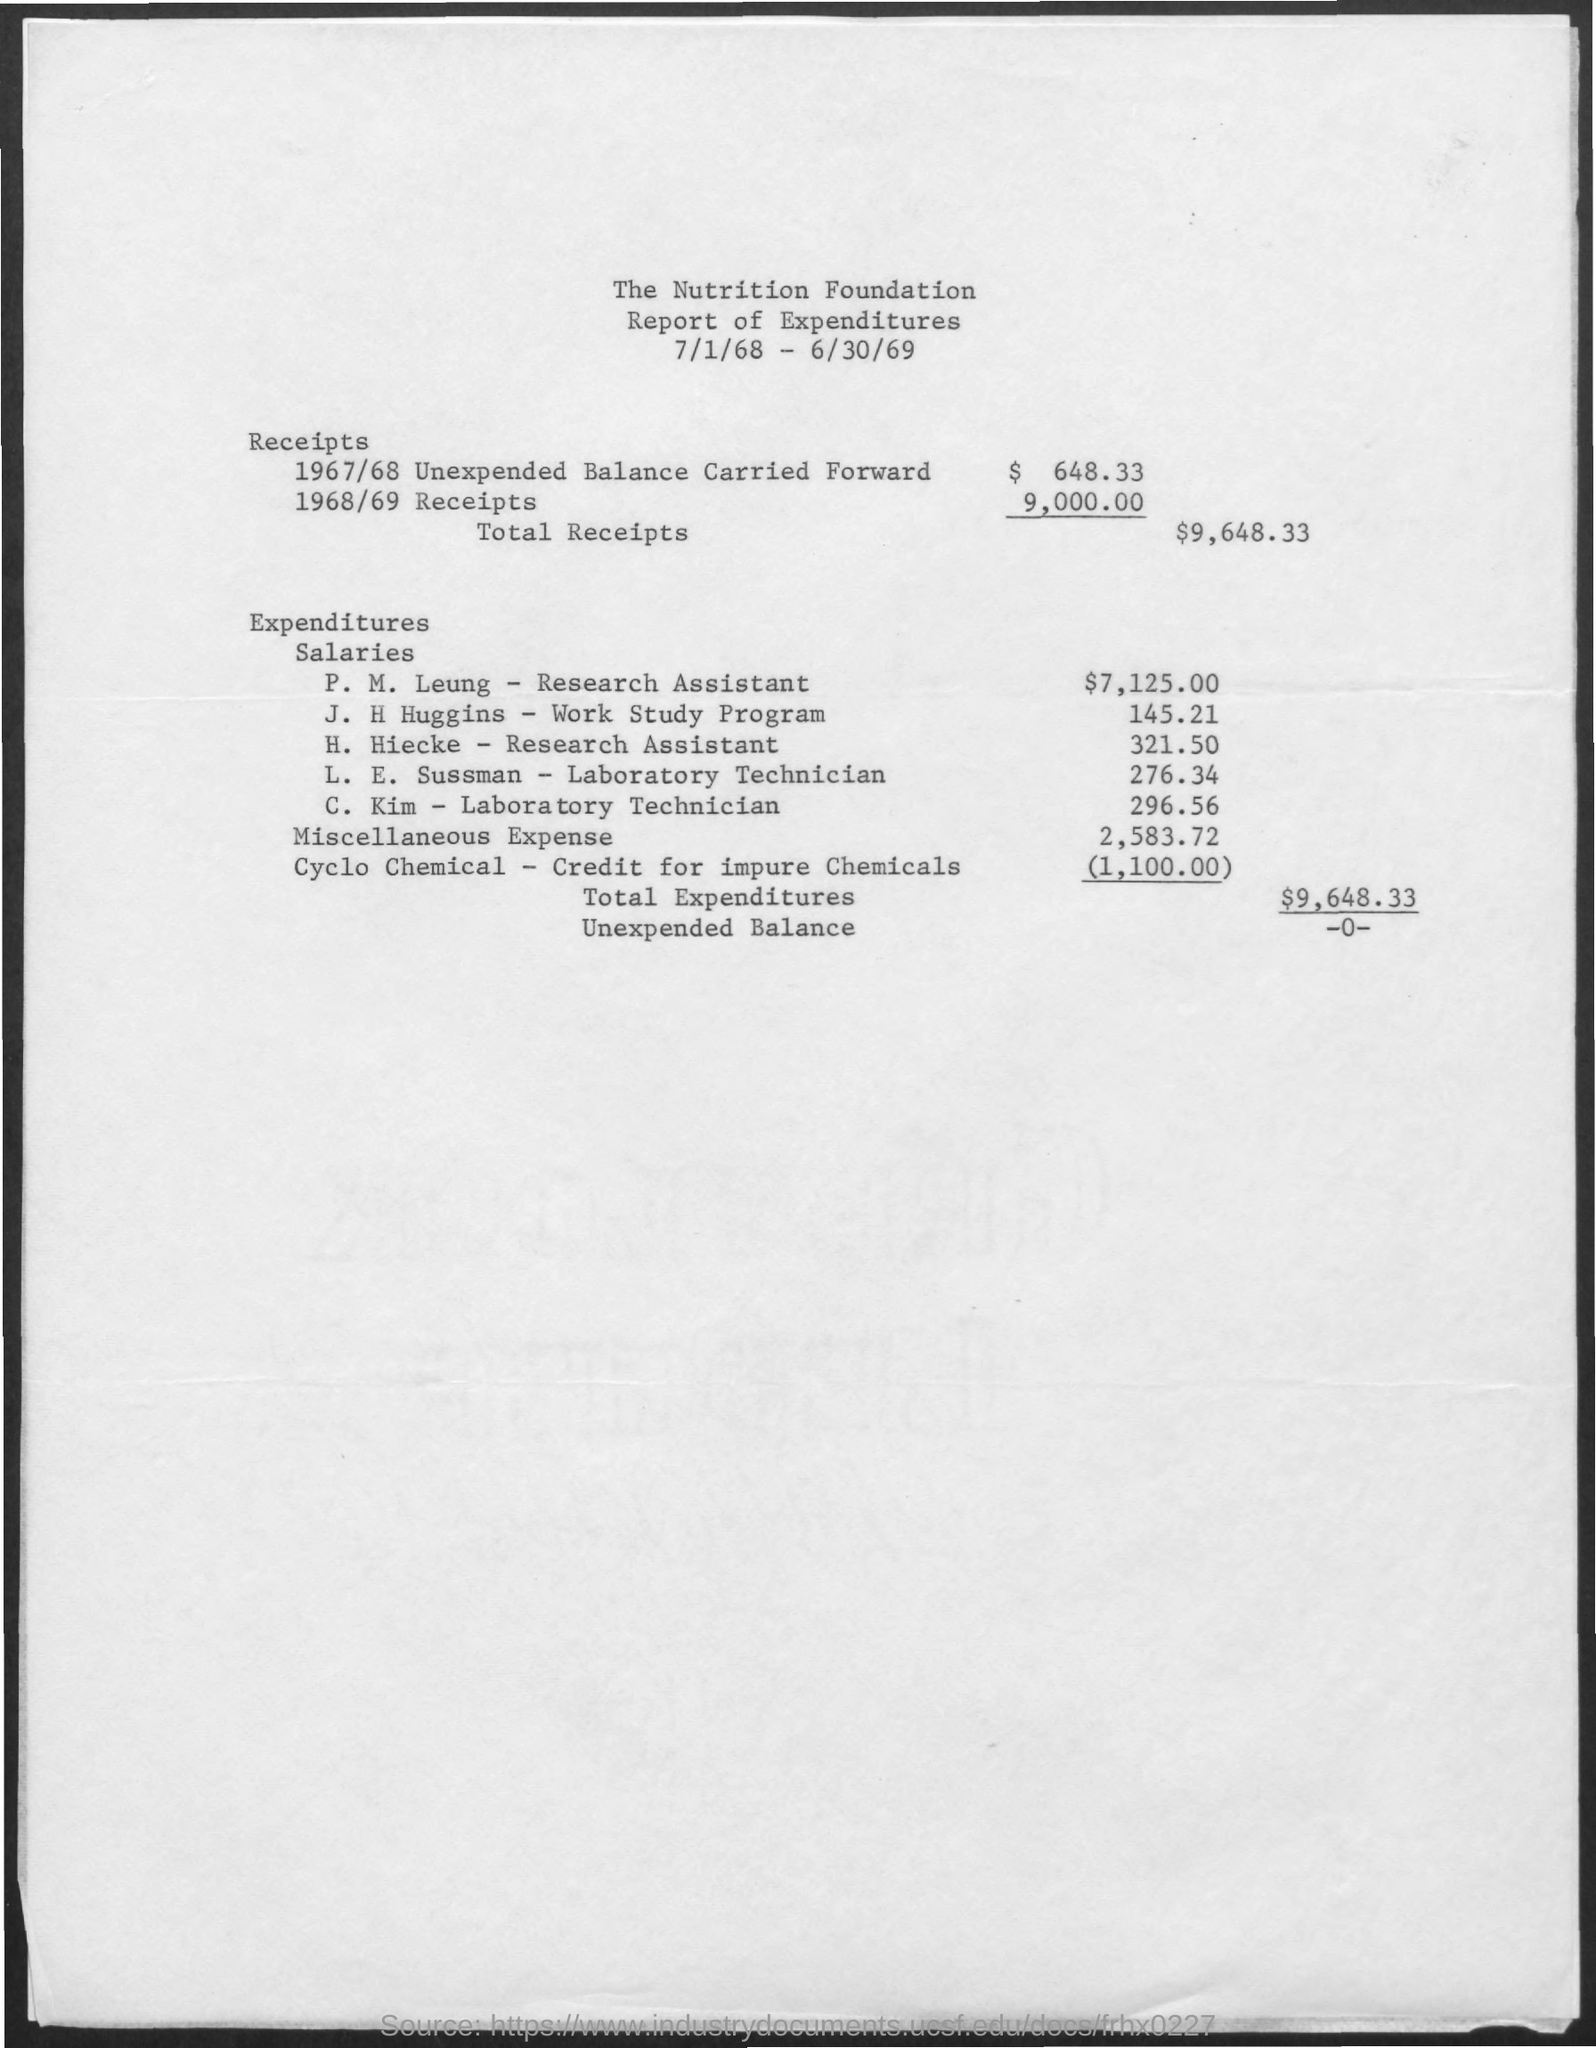List a handful of essential elements in this visual. The miscellaneous expense mentioned in the given report is $2,583.72. L.E. Sussman, a laboratory technician, was given a salary of 276.34 dollars. The salary given to H. Hiecke, research assistant, is 321.50. The salary given to C. Kim, a laboratory technician, is 296.56 dollars. The salary for J.H.Huggins in the work-study program is 145.21. 